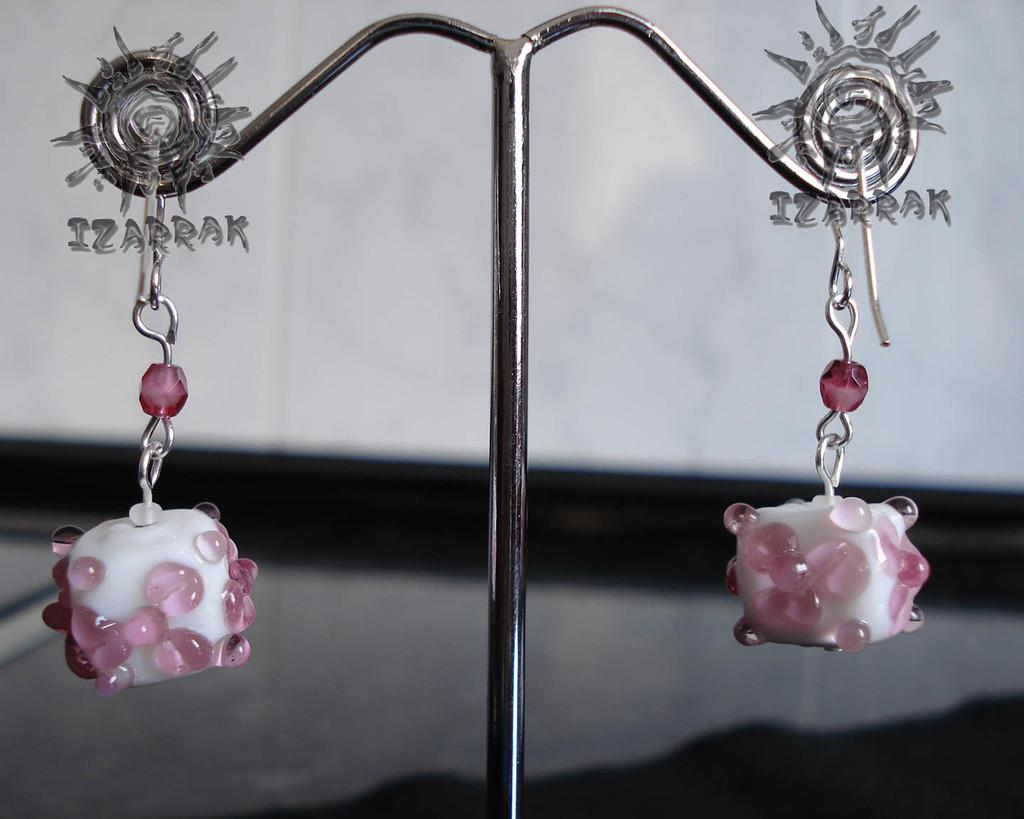How many keychains are visible in the image? There are two keychains in the image. Where are the keychains located? The keychains are on a stand. Can you describe the position of the keychains on the stand? One keychain is on the left side of the stand, and the other keychain is on the right side of the stand. How does the dog wash the boundary in the image? There is no dog or boundary present in the image; it only features two keychains on a stand. 